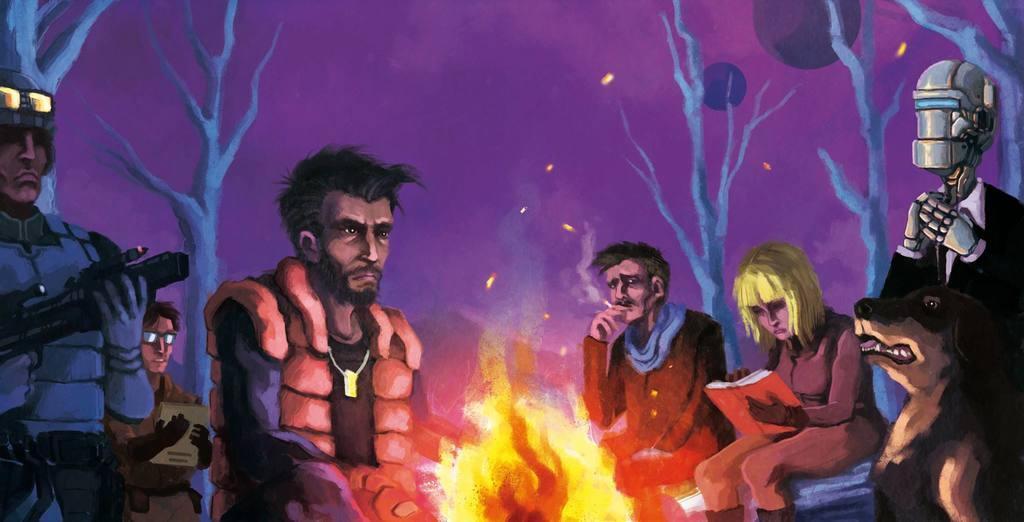Could you give a brief overview of what you see in this image? In this picture we can see a cartoon image, there is fire in the front, we can see some people in the middle, on the right side there is an animal, we can see trees in the background. 